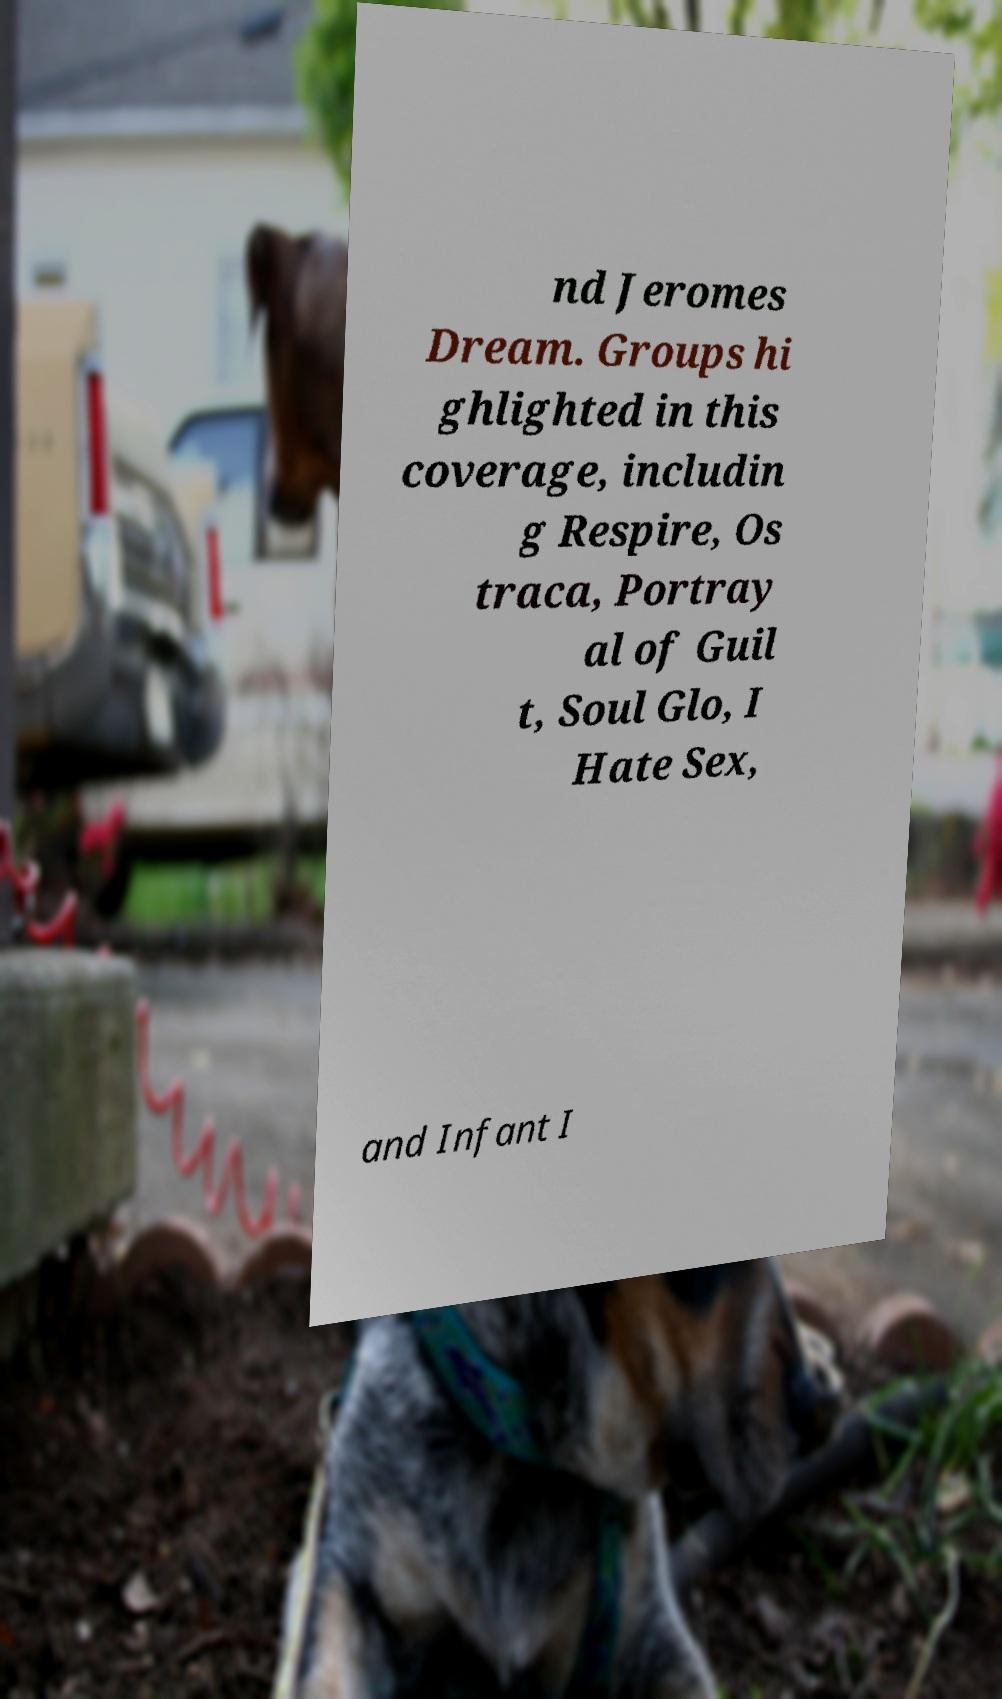Can you accurately transcribe the text from the provided image for me? nd Jeromes Dream. Groups hi ghlighted in this coverage, includin g Respire, Os traca, Portray al of Guil t, Soul Glo, I Hate Sex, and Infant I 